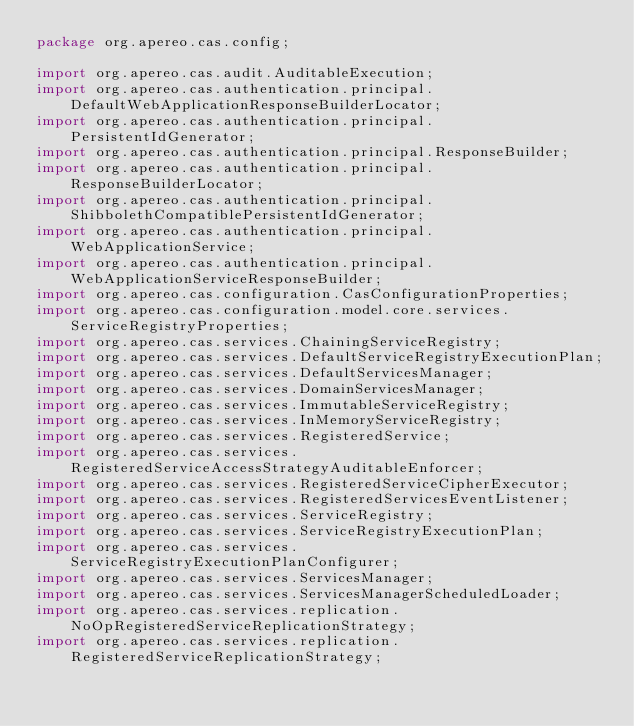Convert code to text. <code><loc_0><loc_0><loc_500><loc_500><_Java_>package org.apereo.cas.config;

import org.apereo.cas.audit.AuditableExecution;
import org.apereo.cas.authentication.principal.DefaultWebApplicationResponseBuilderLocator;
import org.apereo.cas.authentication.principal.PersistentIdGenerator;
import org.apereo.cas.authentication.principal.ResponseBuilder;
import org.apereo.cas.authentication.principal.ResponseBuilderLocator;
import org.apereo.cas.authentication.principal.ShibbolethCompatiblePersistentIdGenerator;
import org.apereo.cas.authentication.principal.WebApplicationService;
import org.apereo.cas.authentication.principal.WebApplicationServiceResponseBuilder;
import org.apereo.cas.configuration.CasConfigurationProperties;
import org.apereo.cas.configuration.model.core.services.ServiceRegistryProperties;
import org.apereo.cas.services.ChainingServiceRegistry;
import org.apereo.cas.services.DefaultServiceRegistryExecutionPlan;
import org.apereo.cas.services.DefaultServicesManager;
import org.apereo.cas.services.DomainServicesManager;
import org.apereo.cas.services.ImmutableServiceRegistry;
import org.apereo.cas.services.InMemoryServiceRegistry;
import org.apereo.cas.services.RegisteredService;
import org.apereo.cas.services.RegisteredServiceAccessStrategyAuditableEnforcer;
import org.apereo.cas.services.RegisteredServiceCipherExecutor;
import org.apereo.cas.services.RegisteredServicesEventListener;
import org.apereo.cas.services.ServiceRegistry;
import org.apereo.cas.services.ServiceRegistryExecutionPlan;
import org.apereo.cas.services.ServiceRegistryExecutionPlanConfigurer;
import org.apereo.cas.services.ServicesManager;
import org.apereo.cas.services.ServicesManagerScheduledLoader;
import org.apereo.cas.services.replication.NoOpRegisteredServiceReplicationStrategy;
import org.apereo.cas.services.replication.RegisteredServiceReplicationStrategy;</code> 